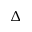Convert formula to latex. <formula><loc_0><loc_0><loc_500><loc_500>\Delta</formula> 